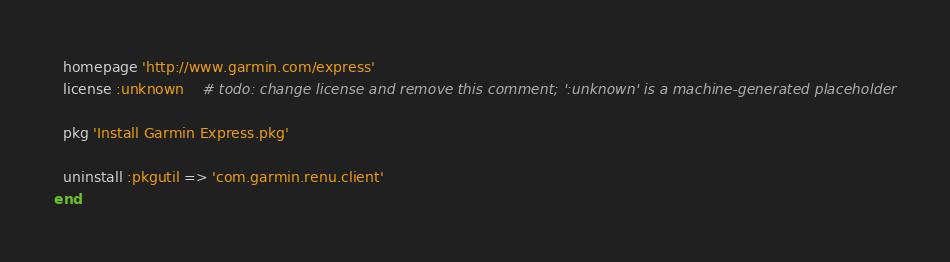Convert code to text. <code><loc_0><loc_0><loc_500><loc_500><_Ruby_>  homepage 'http://www.garmin.com/express'
  license :unknown    # todo: change license and remove this comment; ':unknown' is a machine-generated placeholder

  pkg 'Install Garmin Express.pkg'

  uninstall :pkgutil => 'com.garmin.renu.client'
end
</code> 